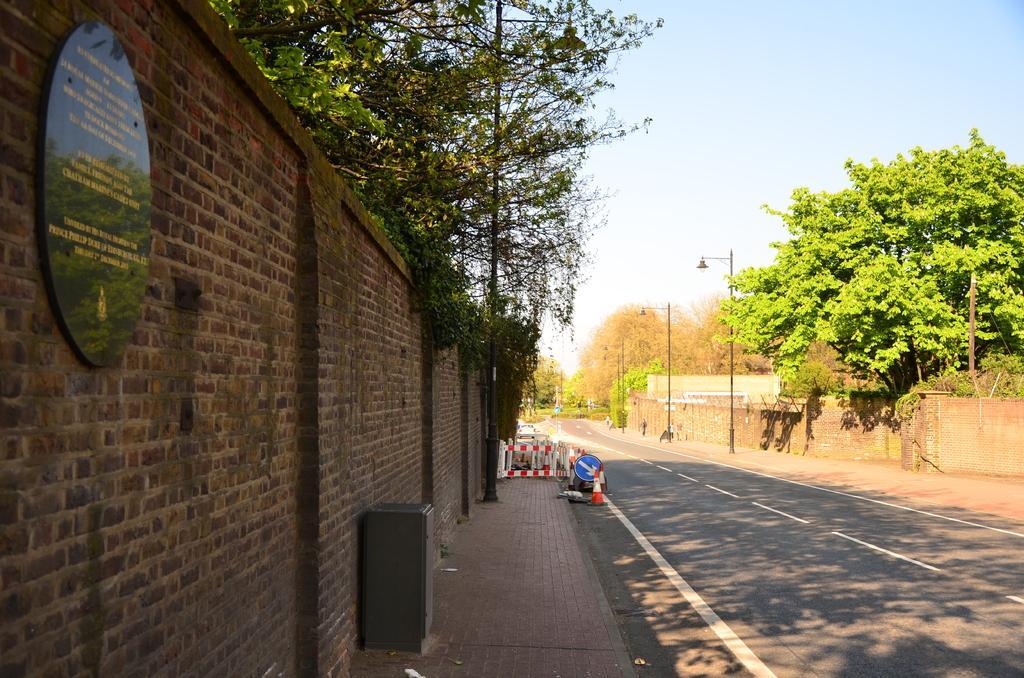Describe this image in one or two sentences. As we can see in the image there is wall, banner, trees, street lamps and sky. 